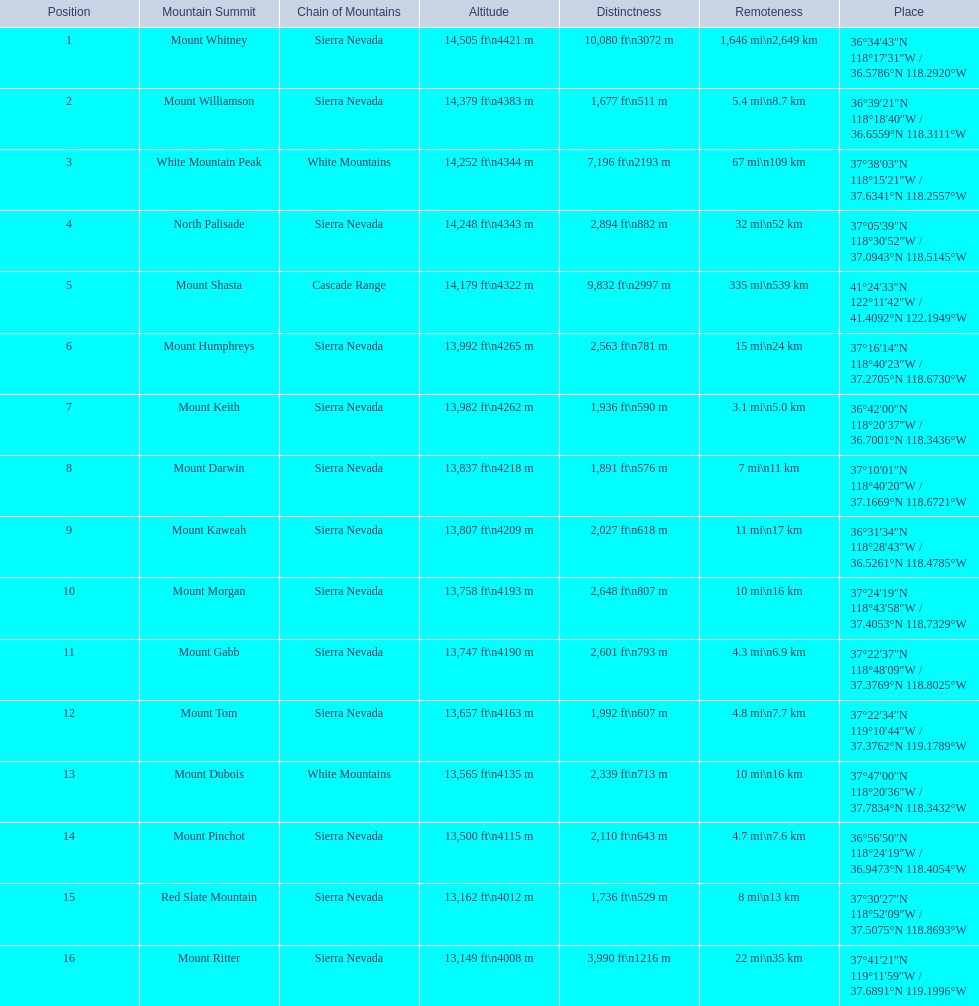What are the heights of the californian mountain peaks? 14,505 ft\n4421 m, 14,379 ft\n4383 m, 14,252 ft\n4344 m, 14,248 ft\n4343 m, 14,179 ft\n4322 m, 13,992 ft\n4265 m, 13,982 ft\n4262 m, 13,837 ft\n4218 m, 13,807 ft\n4209 m, 13,758 ft\n4193 m, 13,747 ft\n4190 m, 13,657 ft\n4163 m, 13,565 ft\n4135 m, 13,500 ft\n4115 m, 13,162 ft\n4012 m, 13,149 ft\n4008 m. What elevation is 13,149 ft or less? 13,149 ft\n4008 m. What mountain peak is at this elevation? Mount Ritter. 